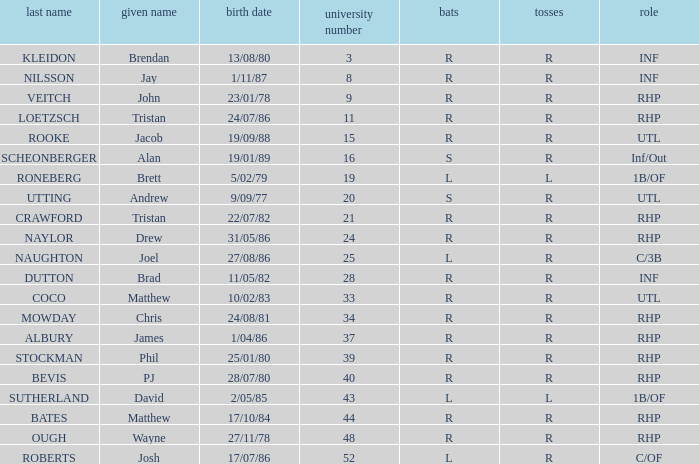Which Position has a Surname of naylor? RHP. 